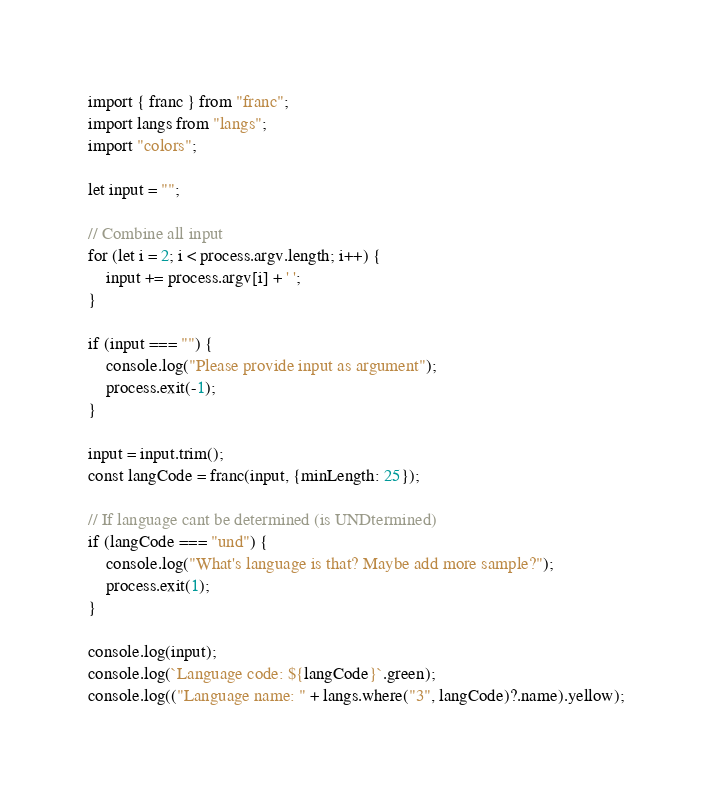<code> <loc_0><loc_0><loc_500><loc_500><_JavaScript_>import { franc } from "franc";
import langs from "langs";
import "colors";

let input = "";

// Combine all input
for (let i = 2; i < process.argv.length; i++) {
    input += process.argv[i] + ' ';
}

if (input === "") {
    console.log("Please provide input as argument");
    process.exit(-1);
}

input = input.trim();
const langCode = franc(input, {minLength: 25});

// If language cant be determined (is UNDtermined)
if (langCode === "und") {
    console.log("What's language is that? Maybe add more sample?");
    process.exit(1);
}

console.log(input);
console.log(`Language code: ${langCode}`.green);
console.log(("Language name: " + langs.where("3", langCode)?.name).yellow);</code> 